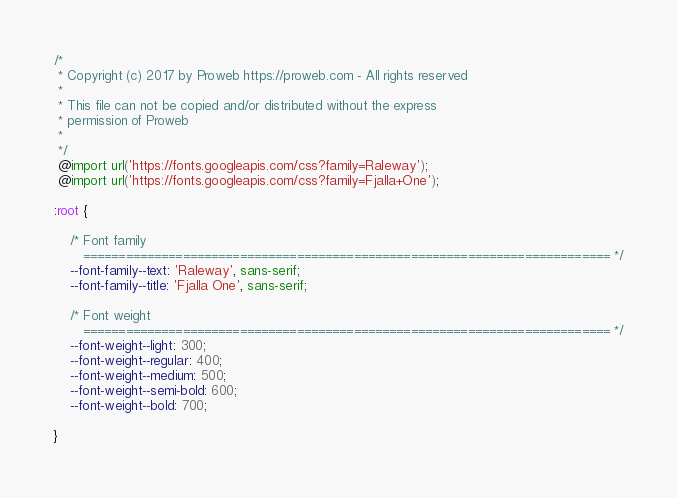Convert code to text. <code><loc_0><loc_0><loc_500><loc_500><_CSS_>/*
 * Copyright (c) 2017 by Proweb https://proweb.com - All rights reserved
 *
 * This file can not be copied and/or distributed without the express
 * permission of Proweb
 *
 */
 @import url('https://fonts.googleapis.com/css?family=Raleway');
 @import url('https://fonts.googleapis.com/css?family=Fjalla+One');

:root {

    /* Font family
       ========================================================================== */
    --font-family--text: 'Raleway', sans-serif;
    --font-family--title: 'Fjalla One', sans-serif;

    /* Font weight
       ========================================================================== */
    --font-weight--light: 300;
    --font-weight--regular: 400;
    --font-weight--medium: 500;
    --font-weight--semi-bold: 600;
    --font-weight--bold: 700;

}
</code> 